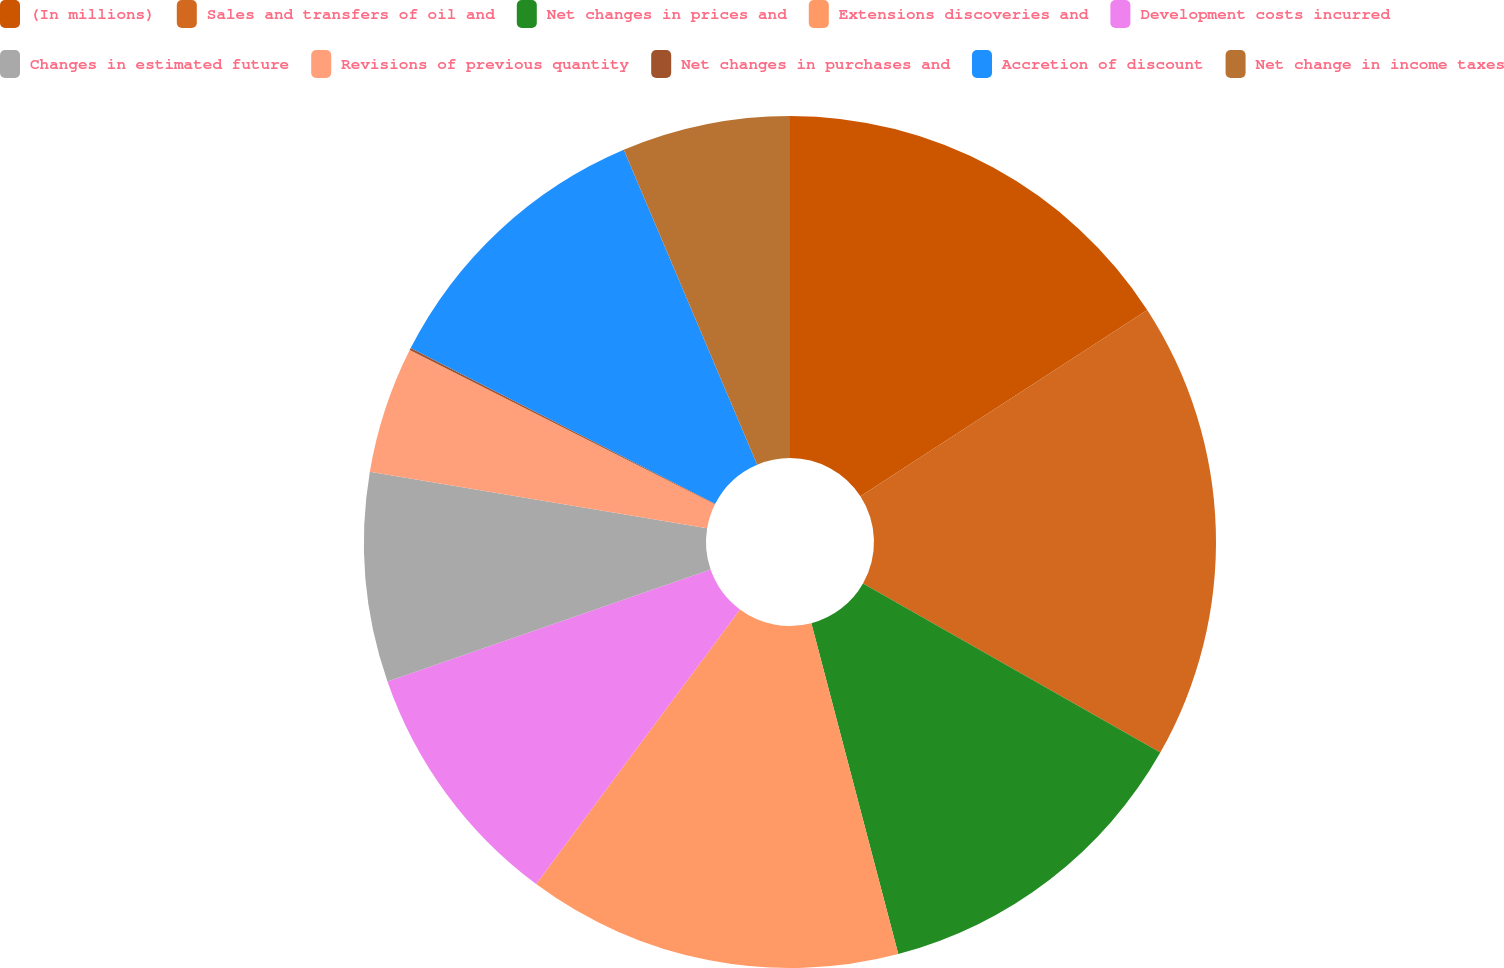Convert chart. <chart><loc_0><loc_0><loc_500><loc_500><pie_chart><fcel>(In millions)<fcel>Sales and transfers of oil and<fcel>Net changes in prices and<fcel>Extensions discoveries and<fcel>Development costs incurred<fcel>Changes in estimated future<fcel>Revisions of previous quantity<fcel>Net changes in purchases and<fcel>Accretion of discount<fcel>Net change in income taxes<nl><fcel>15.83%<fcel>17.4%<fcel>12.68%<fcel>14.25%<fcel>9.53%<fcel>7.95%<fcel>4.8%<fcel>0.08%<fcel>11.1%<fcel>6.38%<nl></chart> 